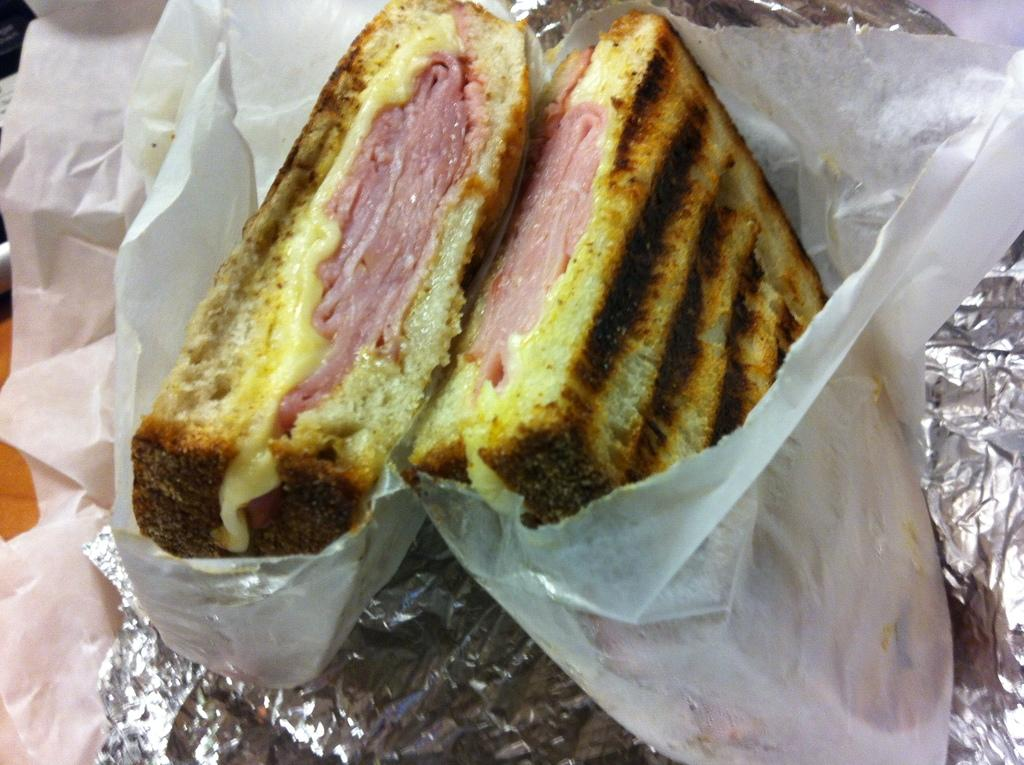What is the main subject of the image? There is a food item in the image. How is the food item wrapped? The food item is wrapped in a white color paper. Is there any additional material associated with the food item? Yes, there is a silver foil associated with the food item. What type of cushion is placed under the food item in the image? There is no cushion present in the image; the focus is on the food item wrapped in white paper and silver foil. 